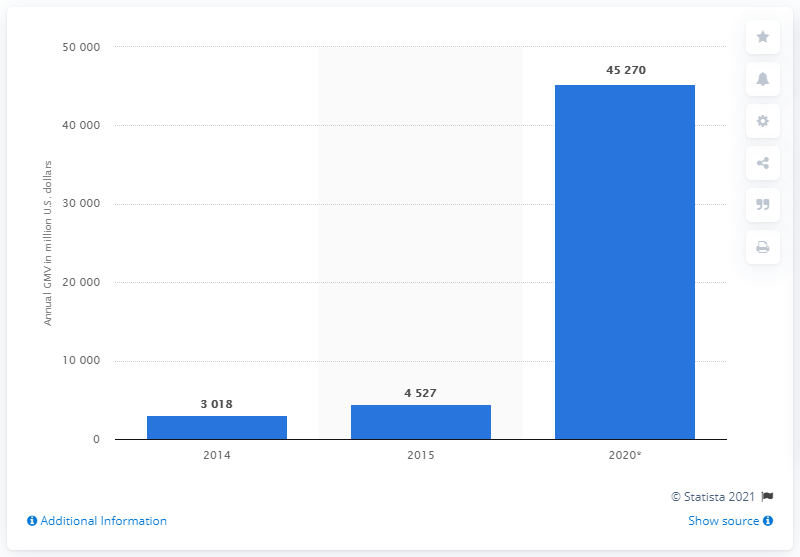Indicate a few pertinent items in this graphic. In 2015, IndiaMART's gross merchandise volume was 3,018. IndiaMART is estimated to have a GMV of approximately 45,270 in 2020. 